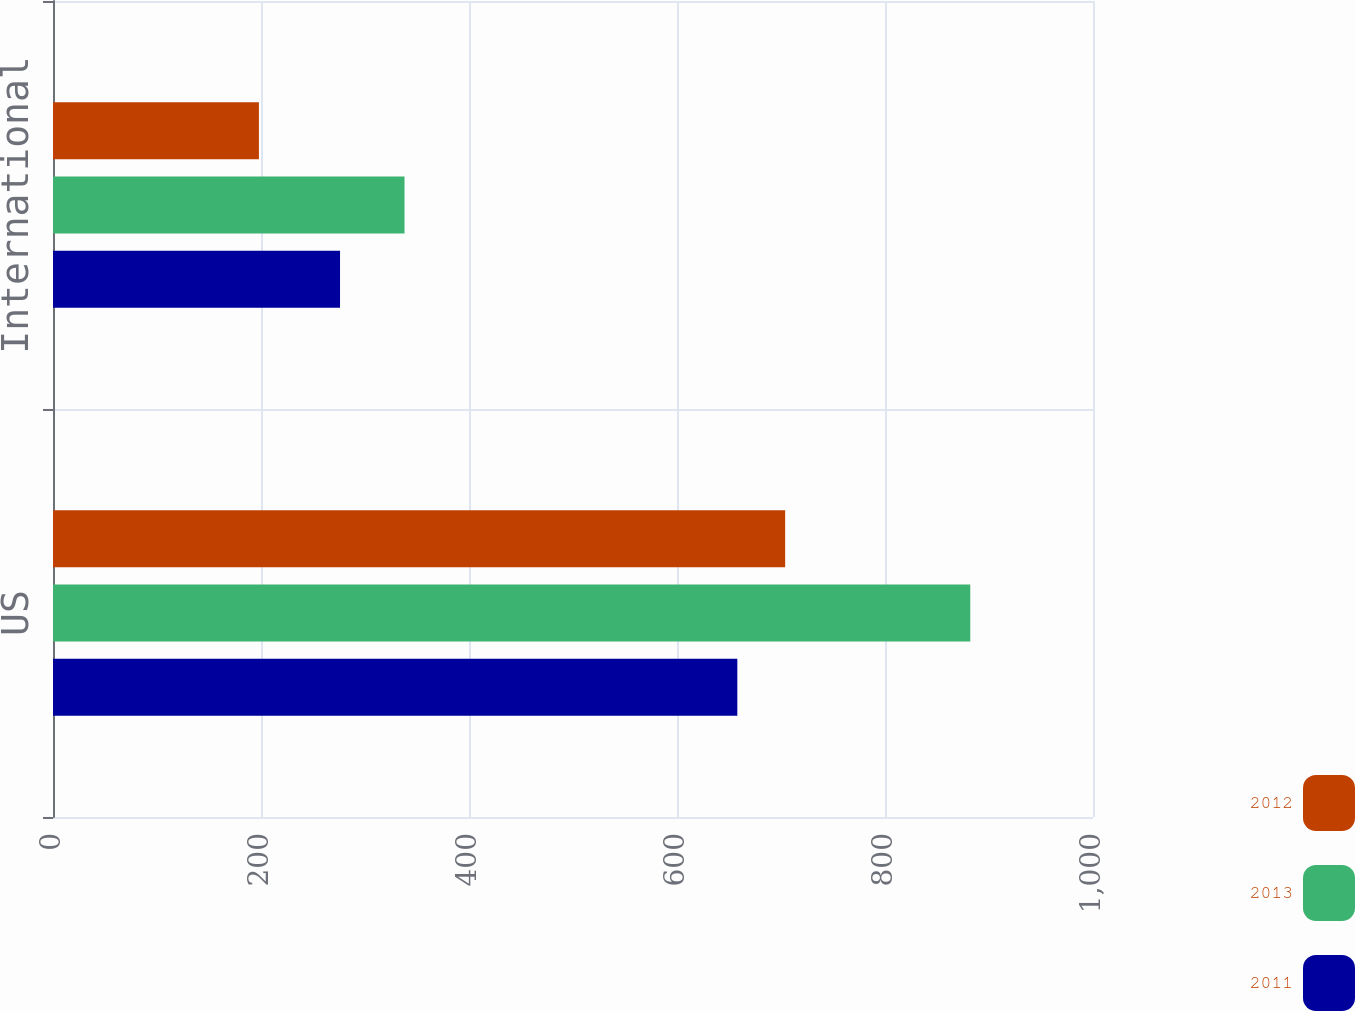Convert chart. <chart><loc_0><loc_0><loc_500><loc_500><stacked_bar_chart><ecel><fcel>US<fcel>International<nl><fcel>2012<fcel>704<fcel>198<nl><fcel>2013<fcel>882<fcel>338<nl><fcel>2011<fcel>658<fcel>276<nl></chart> 